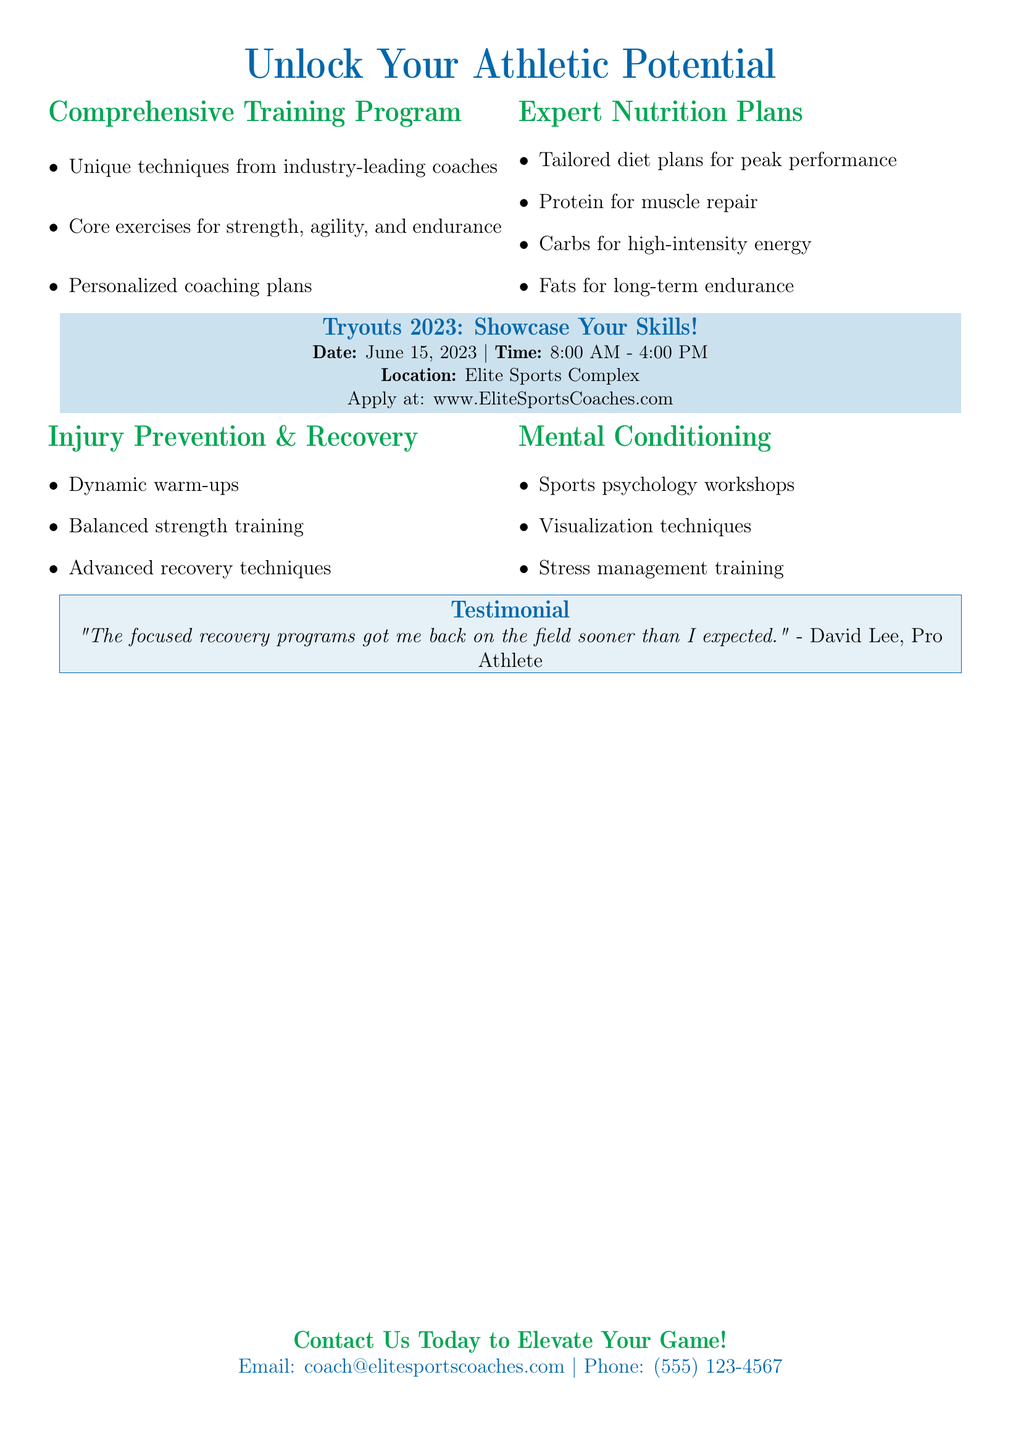What is the title of the program? The title is "Unlock Your Athletic Potential".
Answer: Unlock Your Athletic Potential What is the date of the tryouts? The date specified for the tryouts is listed in the document.
Answer: June 15, 2023 What is the location of the tryouts? The location is provided in the application details for the event.
Answer: Elite Sports Complex What type of training does the program focus on? The document outlines the focus areas mentioned in the comprehensive training program section.
Answer: Strength, agility, and endurance Which strategies are included in the Mental Conditioning section? The section lists specific techniques to enhance performance.
Answer: Visualization techniques Who provided a testimonial in the document? The specific person giving a testimonial is included in the testimonial section.
Answer: David Lee What are the benefits of the Expert Nutrition Plans? The document describes the advantages associated with proper nutrition.
Answer: Peak performance What does the Comprehensive Training Program include? The document lists the components included in the training program.
Answer: Unique techniques, core exercises, personalized coaching What is one of the advanced recovery techniques mentioned? The document specifies the types of recovery techniques discussed.
Answer: Dynamic warm-ups 